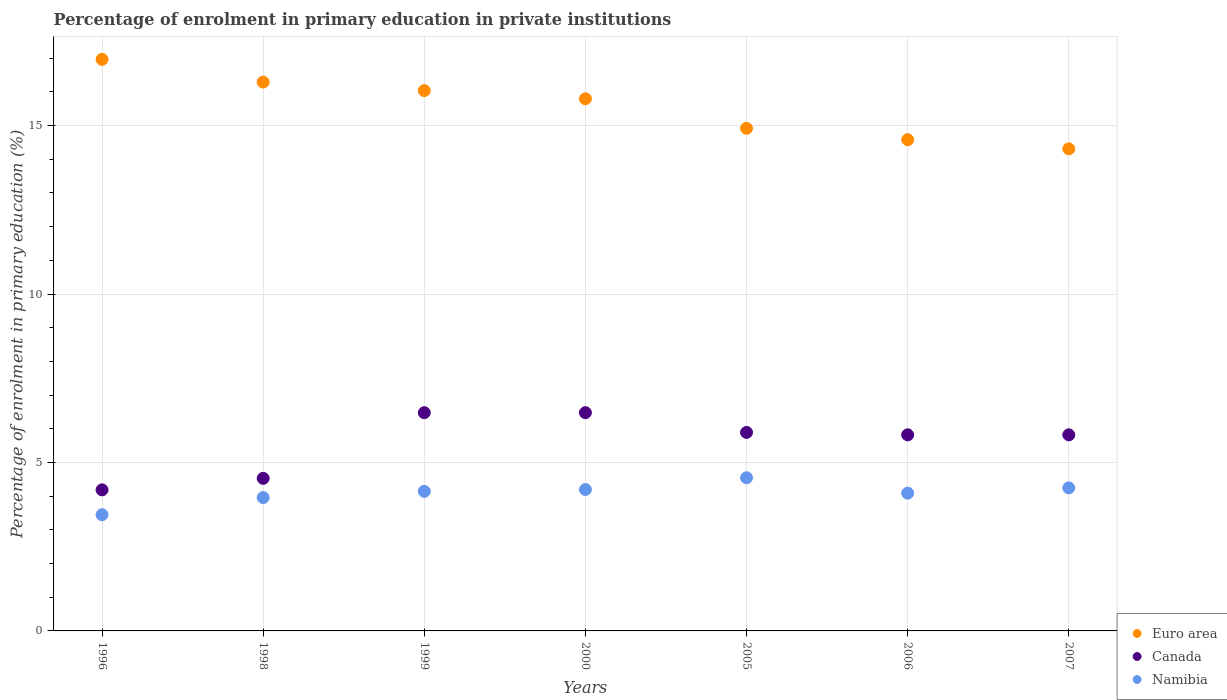What is the percentage of enrolment in primary education in Namibia in 2006?
Ensure brevity in your answer.  4.09. Across all years, what is the maximum percentage of enrolment in primary education in Euro area?
Offer a very short reply. 16.97. Across all years, what is the minimum percentage of enrolment in primary education in Namibia?
Provide a succinct answer. 3.45. In which year was the percentage of enrolment in primary education in Canada maximum?
Provide a succinct answer. 2000. What is the total percentage of enrolment in primary education in Canada in the graph?
Your answer should be very brief. 39.2. What is the difference between the percentage of enrolment in primary education in Namibia in 1996 and that in 1998?
Your response must be concise. -0.51. What is the difference between the percentage of enrolment in primary education in Canada in 1998 and the percentage of enrolment in primary education in Namibia in 1996?
Provide a succinct answer. 1.08. What is the average percentage of enrolment in primary education in Namibia per year?
Offer a terse response. 4.09. In the year 1996, what is the difference between the percentage of enrolment in primary education in Namibia and percentage of enrolment in primary education in Euro area?
Keep it short and to the point. -13.52. What is the ratio of the percentage of enrolment in primary education in Namibia in 2000 to that in 2006?
Offer a very short reply. 1.03. Is the percentage of enrolment in primary education in Canada in 1996 less than that in 2007?
Offer a terse response. Yes. Is the difference between the percentage of enrolment in primary education in Namibia in 1999 and 2000 greater than the difference between the percentage of enrolment in primary education in Euro area in 1999 and 2000?
Make the answer very short. No. What is the difference between the highest and the second highest percentage of enrolment in primary education in Namibia?
Provide a short and direct response. 0.3. What is the difference between the highest and the lowest percentage of enrolment in primary education in Namibia?
Offer a terse response. 1.1. Is it the case that in every year, the sum of the percentage of enrolment in primary education in Euro area and percentage of enrolment in primary education in Canada  is greater than the percentage of enrolment in primary education in Namibia?
Provide a short and direct response. Yes. Does the percentage of enrolment in primary education in Euro area monotonically increase over the years?
Your answer should be very brief. No. How many years are there in the graph?
Offer a terse response. 7. What is the difference between two consecutive major ticks on the Y-axis?
Give a very brief answer. 5. Are the values on the major ticks of Y-axis written in scientific E-notation?
Your answer should be very brief. No. Does the graph contain grids?
Provide a succinct answer. Yes. Where does the legend appear in the graph?
Keep it short and to the point. Bottom right. How many legend labels are there?
Keep it short and to the point. 3. What is the title of the graph?
Give a very brief answer. Percentage of enrolment in primary education in private institutions. What is the label or title of the X-axis?
Offer a terse response. Years. What is the label or title of the Y-axis?
Ensure brevity in your answer.  Percentage of enrolment in primary education (%). What is the Percentage of enrolment in primary education (%) of Euro area in 1996?
Give a very brief answer. 16.97. What is the Percentage of enrolment in primary education (%) in Canada in 1996?
Offer a very short reply. 4.19. What is the Percentage of enrolment in primary education (%) in Namibia in 1996?
Keep it short and to the point. 3.45. What is the Percentage of enrolment in primary education (%) in Euro area in 1998?
Provide a short and direct response. 16.29. What is the Percentage of enrolment in primary education (%) of Canada in 1998?
Give a very brief answer. 4.53. What is the Percentage of enrolment in primary education (%) in Namibia in 1998?
Provide a succinct answer. 3.96. What is the Percentage of enrolment in primary education (%) of Euro area in 1999?
Provide a short and direct response. 16.04. What is the Percentage of enrolment in primary education (%) of Canada in 1999?
Offer a very short reply. 6.48. What is the Percentage of enrolment in primary education (%) of Namibia in 1999?
Provide a succinct answer. 4.14. What is the Percentage of enrolment in primary education (%) of Euro area in 2000?
Ensure brevity in your answer.  15.8. What is the Percentage of enrolment in primary education (%) in Canada in 2000?
Ensure brevity in your answer.  6.48. What is the Percentage of enrolment in primary education (%) in Namibia in 2000?
Your response must be concise. 4.2. What is the Percentage of enrolment in primary education (%) in Euro area in 2005?
Your answer should be compact. 14.92. What is the Percentage of enrolment in primary education (%) of Canada in 2005?
Ensure brevity in your answer.  5.89. What is the Percentage of enrolment in primary education (%) in Namibia in 2005?
Your answer should be very brief. 4.55. What is the Percentage of enrolment in primary education (%) of Euro area in 2006?
Ensure brevity in your answer.  14.58. What is the Percentage of enrolment in primary education (%) in Canada in 2006?
Your answer should be very brief. 5.82. What is the Percentage of enrolment in primary education (%) of Namibia in 2006?
Provide a short and direct response. 4.09. What is the Percentage of enrolment in primary education (%) of Euro area in 2007?
Your response must be concise. 14.31. What is the Percentage of enrolment in primary education (%) of Canada in 2007?
Keep it short and to the point. 5.82. What is the Percentage of enrolment in primary education (%) of Namibia in 2007?
Offer a very short reply. 4.25. Across all years, what is the maximum Percentage of enrolment in primary education (%) in Euro area?
Your response must be concise. 16.97. Across all years, what is the maximum Percentage of enrolment in primary education (%) in Canada?
Your answer should be compact. 6.48. Across all years, what is the maximum Percentage of enrolment in primary education (%) in Namibia?
Your answer should be very brief. 4.55. Across all years, what is the minimum Percentage of enrolment in primary education (%) in Euro area?
Provide a short and direct response. 14.31. Across all years, what is the minimum Percentage of enrolment in primary education (%) in Canada?
Offer a terse response. 4.19. Across all years, what is the minimum Percentage of enrolment in primary education (%) of Namibia?
Give a very brief answer. 3.45. What is the total Percentage of enrolment in primary education (%) of Euro area in the graph?
Ensure brevity in your answer.  108.9. What is the total Percentage of enrolment in primary education (%) in Canada in the graph?
Give a very brief answer. 39.2. What is the total Percentage of enrolment in primary education (%) of Namibia in the graph?
Keep it short and to the point. 28.63. What is the difference between the Percentage of enrolment in primary education (%) of Euro area in 1996 and that in 1998?
Your response must be concise. 0.67. What is the difference between the Percentage of enrolment in primary education (%) in Canada in 1996 and that in 1998?
Offer a terse response. -0.34. What is the difference between the Percentage of enrolment in primary education (%) of Namibia in 1996 and that in 1998?
Your response must be concise. -0.51. What is the difference between the Percentage of enrolment in primary education (%) of Euro area in 1996 and that in 1999?
Provide a succinct answer. 0.93. What is the difference between the Percentage of enrolment in primary education (%) of Canada in 1996 and that in 1999?
Your answer should be very brief. -2.29. What is the difference between the Percentage of enrolment in primary education (%) of Namibia in 1996 and that in 1999?
Your response must be concise. -0.69. What is the difference between the Percentage of enrolment in primary education (%) of Euro area in 1996 and that in 2000?
Keep it short and to the point. 1.17. What is the difference between the Percentage of enrolment in primary education (%) in Canada in 1996 and that in 2000?
Ensure brevity in your answer.  -2.29. What is the difference between the Percentage of enrolment in primary education (%) of Namibia in 1996 and that in 2000?
Give a very brief answer. -0.75. What is the difference between the Percentage of enrolment in primary education (%) of Euro area in 1996 and that in 2005?
Your response must be concise. 2.05. What is the difference between the Percentage of enrolment in primary education (%) of Canada in 1996 and that in 2005?
Your response must be concise. -1.7. What is the difference between the Percentage of enrolment in primary education (%) of Namibia in 1996 and that in 2005?
Your answer should be compact. -1.1. What is the difference between the Percentage of enrolment in primary education (%) of Euro area in 1996 and that in 2006?
Offer a very short reply. 2.39. What is the difference between the Percentage of enrolment in primary education (%) in Canada in 1996 and that in 2006?
Keep it short and to the point. -1.63. What is the difference between the Percentage of enrolment in primary education (%) of Namibia in 1996 and that in 2006?
Give a very brief answer. -0.64. What is the difference between the Percentage of enrolment in primary education (%) of Euro area in 1996 and that in 2007?
Give a very brief answer. 2.66. What is the difference between the Percentage of enrolment in primary education (%) of Canada in 1996 and that in 2007?
Make the answer very short. -1.63. What is the difference between the Percentage of enrolment in primary education (%) of Namibia in 1996 and that in 2007?
Ensure brevity in your answer.  -0.8. What is the difference between the Percentage of enrolment in primary education (%) in Euro area in 1998 and that in 1999?
Give a very brief answer. 0.25. What is the difference between the Percentage of enrolment in primary education (%) in Canada in 1998 and that in 1999?
Offer a very short reply. -1.95. What is the difference between the Percentage of enrolment in primary education (%) in Namibia in 1998 and that in 1999?
Provide a short and direct response. -0.19. What is the difference between the Percentage of enrolment in primary education (%) of Euro area in 1998 and that in 2000?
Keep it short and to the point. 0.5. What is the difference between the Percentage of enrolment in primary education (%) of Canada in 1998 and that in 2000?
Make the answer very short. -1.95. What is the difference between the Percentage of enrolment in primary education (%) of Namibia in 1998 and that in 2000?
Your answer should be very brief. -0.24. What is the difference between the Percentage of enrolment in primary education (%) in Euro area in 1998 and that in 2005?
Keep it short and to the point. 1.37. What is the difference between the Percentage of enrolment in primary education (%) of Canada in 1998 and that in 2005?
Give a very brief answer. -1.36. What is the difference between the Percentage of enrolment in primary education (%) of Namibia in 1998 and that in 2005?
Your response must be concise. -0.59. What is the difference between the Percentage of enrolment in primary education (%) of Euro area in 1998 and that in 2006?
Offer a terse response. 1.71. What is the difference between the Percentage of enrolment in primary education (%) in Canada in 1998 and that in 2006?
Provide a succinct answer. -1.29. What is the difference between the Percentage of enrolment in primary education (%) of Namibia in 1998 and that in 2006?
Provide a succinct answer. -0.13. What is the difference between the Percentage of enrolment in primary education (%) of Euro area in 1998 and that in 2007?
Offer a very short reply. 1.98. What is the difference between the Percentage of enrolment in primary education (%) of Canada in 1998 and that in 2007?
Make the answer very short. -1.29. What is the difference between the Percentage of enrolment in primary education (%) of Namibia in 1998 and that in 2007?
Your response must be concise. -0.29. What is the difference between the Percentage of enrolment in primary education (%) of Euro area in 1999 and that in 2000?
Make the answer very short. 0.24. What is the difference between the Percentage of enrolment in primary education (%) in Canada in 1999 and that in 2000?
Provide a succinct answer. -0. What is the difference between the Percentage of enrolment in primary education (%) of Namibia in 1999 and that in 2000?
Your answer should be very brief. -0.05. What is the difference between the Percentage of enrolment in primary education (%) in Euro area in 1999 and that in 2005?
Your answer should be very brief. 1.12. What is the difference between the Percentage of enrolment in primary education (%) in Canada in 1999 and that in 2005?
Offer a very short reply. 0.59. What is the difference between the Percentage of enrolment in primary education (%) of Namibia in 1999 and that in 2005?
Provide a short and direct response. -0.4. What is the difference between the Percentage of enrolment in primary education (%) in Euro area in 1999 and that in 2006?
Offer a terse response. 1.46. What is the difference between the Percentage of enrolment in primary education (%) in Canada in 1999 and that in 2006?
Provide a short and direct response. 0.66. What is the difference between the Percentage of enrolment in primary education (%) in Namibia in 1999 and that in 2006?
Ensure brevity in your answer.  0.05. What is the difference between the Percentage of enrolment in primary education (%) of Euro area in 1999 and that in 2007?
Make the answer very short. 1.73. What is the difference between the Percentage of enrolment in primary education (%) of Canada in 1999 and that in 2007?
Your response must be concise. 0.66. What is the difference between the Percentage of enrolment in primary education (%) of Namibia in 1999 and that in 2007?
Provide a short and direct response. -0.1. What is the difference between the Percentage of enrolment in primary education (%) of Euro area in 2000 and that in 2005?
Offer a very short reply. 0.88. What is the difference between the Percentage of enrolment in primary education (%) of Canada in 2000 and that in 2005?
Offer a very short reply. 0.59. What is the difference between the Percentage of enrolment in primary education (%) in Namibia in 2000 and that in 2005?
Ensure brevity in your answer.  -0.35. What is the difference between the Percentage of enrolment in primary education (%) in Euro area in 2000 and that in 2006?
Your answer should be very brief. 1.22. What is the difference between the Percentage of enrolment in primary education (%) of Canada in 2000 and that in 2006?
Your answer should be very brief. 0.66. What is the difference between the Percentage of enrolment in primary education (%) of Namibia in 2000 and that in 2006?
Your answer should be very brief. 0.11. What is the difference between the Percentage of enrolment in primary education (%) in Euro area in 2000 and that in 2007?
Provide a short and direct response. 1.49. What is the difference between the Percentage of enrolment in primary education (%) of Canada in 2000 and that in 2007?
Offer a very short reply. 0.66. What is the difference between the Percentage of enrolment in primary education (%) in Namibia in 2000 and that in 2007?
Offer a very short reply. -0.05. What is the difference between the Percentage of enrolment in primary education (%) in Euro area in 2005 and that in 2006?
Offer a terse response. 0.34. What is the difference between the Percentage of enrolment in primary education (%) of Canada in 2005 and that in 2006?
Offer a very short reply. 0.07. What is the difference between the Percentage of enrolment in primary education (%) in Namibia in 2005 and that in 2006?
Make the answer very short. 0.46. What is the difference between the Percentage of enrolment in primary education (%) of Euro area in 2005 and that in 2007?
Provide a succinct answer. 0.61. What is the difference between the Percentage of enrolment in primary education (%) of Canada in 2005 and that in 2007?
Your answer should be very brief. 0.07. What is the difference between the Percentage of enrolment in primary education (%) in Namibia in 2005 and that in 2007?
Offer a very short reply. 0.3. What is the difference between the Percentage of enrolment in primary education (%) of Euro area in 2006 and that in 2007?
Provide a short and direct response. 0.27. What is the difference between the Percentage of enrolment in primary education (%) of Canada in 2006 and that in 2007?
Give a very brief answer. 0. What is the difference between the Percentage of enrolment in primary education (%) of Namibia in 2006 and that in 2007?
Your response must be concise. -0.16. What is the difference between the Percentage of enrolment in primary education (%) of Euro area in 1996 and the Percentage of enrolment in primary education (%) of Canada in 1998?
Offer a terse response. 12.44. What is the difference between the Percentage of enrolment in primary education (%) in Euro area in 1996 and the Percentage of enrolment in primary education (%) in Namibia in 1998?
Make the answer very short. 13.01. What is the difference between the Percentage of enrolment in primary education (%) of Canada in 1996 and the Percentage of enrolment in primary education (%) of Namibia in 1998?
Make the answer very short. 0.23. What is the difference between the Percentage of enrolment in primary education (%) of Euro area in 1996 and the Percentage of enrolment in primary education (%) of Canada in 1999?
Give a very brief answer. 10.49. What is the difference between the Percentage of enrolment in primary education (%) of Euro area in 1996 and the Percentage of enrolment in primary education (%) of Namibia in 1999?
Your answer should be compact. 12.82. What is the difference between the Percentage of enrolment in primary education (%) in Canada in 1996 and the Percentage of enrolment in primary education (%) in Namibia in 1999?
Your response must be concise. 0.04. What is the difference between the Percentage of enrolment in primary education (%) of Euro area in 1996 and the Percentage of enrolment in primary education (%) of Canada in 2000?
Provide a short and direct response. 10.49. What is the difference between the Percentage of enrolment in primary education (%) in Euro area in 1996 and the Percentage of enrolment in primary education (%) in Namibia in 2000?
Ensure brevity in your answer.  12.77. What is the difference between the Percentage of enrolment in primary education (%) of Canada in 1996 and the Percentage of enrolment in primary education (%) of Namibia in 2000?
Your response must be concise. -0.01. What is the difference between the Percentage of enrolment in primary education (%) of Euro area in 1996 and the Percentage of enrolment in primary education (%) of Canada in 2005?
Offer a very short reply. 11.07. What is the difference between the Percentage of enrolment in primary education (%) of Euro area in 1996 and the Percentage of enrolment in primary education (%) of Namibia in 2005?
Offer a terse response. 12.42. What is the difference between the Percentage of enrolment in primary education (%) of Canada in 1996 and the Percentage of enrolment in primary education (%) of Namibia in 2005?
Keep it short and to the point. -0.36. What is the difference between the Percentage of enrolment in primary education (%) in Euro area in 1996 and the Percentage of enrolment in primary education (%) in Canada in 2006?
Keep it short and to the point. 11.15. What is the difference between the Percentage of enrolment in primary education (%) in Euro area in 1996 and the Percentage of enrolment in primary education (%) in Namibia in 2006?
Provide a short and direct response. 12.88. What is the difference between the Percentage of enrolment in primary education (%) of Canada in 1996 and the Percentage of enrolment in primary education (%) of Namibia in 2006?
Make the answer very short. 0.1. What is the difference between the Percentage of enrolment in primary education (%) in Euro area in 1996 and the Percentage of enrolment in primary education (%) in Canada in 2007?
Offer a terse response. 11.15. What is the difference between the Percentage of enrolment in primary education (%) of Euro area in 1996 and the Percentage of enrolment in primary education (%) of Namibia in 2007?
Your response must be concise. 12.72. What is the difference between the Percentage of enrolment in primary education (%) of Canada in 1996 and the Percentage of enrolment in primary education (%) of Namibia in 2007?
Your response must be concise. -0.06. What is the difference between the Percentage of enrolment in primary education (%) in Euro area in 1998 and the Percentage of enrolment in primary education (%) in Canada in 1999?
Your answer should be very brief. 9.81. What is the difference between the Percentage of enrolment in primary education (%) of Euro area in 1998 and the Percentage of enrolment in primary education (%) of Namibia in 1999?
Your response must be concise. 12.15. What is the difference between the Percentage of enrolment in primary education (%) in Canada in 1998 and the Percentage of enrolment in primary education (%) in Namibia in 1999?
Offer a very short reply. 0.39. What is the difference between the Percentage of enrolment in primary education (%) in Euro area in 1998 and the Percentage of enrolment in primary education (%) in Canada in 2000?
Make the answer very short. 9.81. What is the difference between the Percentage of enrolment in primary education (%) in Euro area in 1998 and the Percentage of enrolment in primary education (%) in Namibia in 2000?
Keep it short and to the point. 12.09. What is the difference between the Percentage of enrolment in primary education (%) of Canada in 1998 and the Percentage of enrolment in primary education (%) of Namibia in 2000?
Your response must be concise. 0.33. What is the difference between the Percentage of enrolment in primary education (%) of Euro area in 1998 and the Percentage of enrolment in primary education (%) of Canada in 2005?
Provide a short and direct response. 10.4. What is the difference between the Percentage of enrolment in primary education (%) in Euro area in 1998 and the Percentage of enrolment in primary education (%) in Namibia in 2005?
Keep it short and to the point. 11.74. What is the difference between the Percentage of enrolment in primary education (%) in Canada in 1998 and the Percentage of enrolment in primary education (%) in Namibia in 2005?
Provide a succinct answer. -0.02. What is the difference between the Percentage of enrolment in primary education (%) in Euro area in 1998 and the Percentage of enrolment in primary education (%) in Canada in 2006?
Your response must be concise. 10.47. What is the difference between the Percentage of enrolment in primary education (%) of Euro area in 1998 and the Percentage of enrolment in primary education (%) of Namibia in 2006?
Ensure brevity in your answer.  12.2. What is the difference between the Percentage of enrolment in primary education (%) of Canada in 1998 and the Percentage of enrolment in primary education (%) of Namibia in 2006?
Your answer should be compact. 0.44. What is the difference between the Percentage of enrolment in primary education (%) in Euro area in 1998 and the Percentage of enrolment in primary education (%) in Canada in 2007?
Provide a short and direct response. 10.47. What is the difference between the Percentage of enrolment in primary education (%) of Euro area in 1998 and the Percentage of enrolment in primary education (%) of Namibia in 2007?
Your answer should be compact. 12.04. What is the difference between the Percentage of enrolment in primary education (%) of Canada in 1998 and the Percentage of enrolment in primary education (%) of Namibia in 2007?
Offer a terse response. 0.28. What is the difference between the Percentage of enrolment in primary education (%) of Euro area in 1999 and the Percentage of enrolment in primary education (%) of Canada in 2000?
Ensure brevity in your answer.  9.56. What is the difference between the Percentage of enrolment in primary education (%) of Euro area in 1999 and the Percentage of enrolment in primary education (%) of Namibia in 2000?
Make the answer very short. 11.84. What is the difference between the Percentage of enrolment in primary education (%) of Canada in 1999 and the Percentage of enrolment in primary education (%) of Namibia in 2000?
Provide a succinct answer. 2.28. What is the difference between the Percentage of enrolment in primary education (%) in Euro area in 1999 and the Percentage of enrolment in primary education (%) in Canada in 2005?
Your answer should be compact. 10.15. What is the difference between the Percentage of enrolment in primary education (%) of Euro area in 1999 and the Percentage of enrolment in primary education (%) of Namibia in 2005?
Offer a terse response. 11.49. What is the difference between the Percentage of enrolment in primary education (%) in Canada in 1999 and the Percentage of enrolment in primary education (%) in Namibia in 2005?
Provide a succinct answer. 1.93. What is the difference between the Percentage of enrolment in primary education (%) in Euro area in 1999 and the Percentage of enrolment in primary education (%) in Canada in 2006?
Your response must be concise. 10.22. What is the difference between the Percentage of enrolment in primary education (%) in Euro area in 1999 and the Percentage of enrolment in primary education (%) in Namibia in 2006?
Keep it short and to the point. 11.95. What is the difference between the Percentage of enrolment in primary education (%) of Canada in 1999 and the Percentage of enrolment in primary education (%) of Namibia in 2006?
Make the answer very short. 2.39. What is the difference between the Percentage of enrolment in primary education (%) in Euro area in 1999 and the Percentage of enrolment in primary education (%) in Canada in 2007?
Offer a very short reply. 10.22. What is the difference between the Percentage of enrolment in primary education (%) of Euro area in 1999 and the Percentage of enrolment in primary education (%) of Namibia in 2007?
Your answer should be compact. 11.79. What is the difference between the Percentage of enrolment in primary education (%) of Canada in 1999 and the Percentage of enrolment in primary education (%) of Namibia in 2007?
Make the answer very short. 2.23. What is the difference between the Percentage of enrolment in primary education (%) of Euro area in 2000 and the Percentage of enrolment in primary education (%) of Canada in 2005?
Offer a terse response. 9.9. What is the difference between the Percentage of enrolment in primary education (%) in Euro area in 2000 and the Percentage of enrolment in primary education (%) in Namibia in 2005?
Your answer should be very brief. 11.25. What is the difference between the Percentage of enrolment in primary education (%) in Canada in 2000 and the Percentage of enrolment in primary education (%) in Namibia in 2005?
Give a very brief answer. 1.93. What is the difference between the Percentage of enrolment in primary education (%) in Euro area in 2000 and the Percentage of enrolment in primary education (%) in Canada in 2006?
Provide a short and direct response. 9.98. What is the difference between the Percentage of enrolment in primary education (%) in Euro area in 2000 and the Percentage of enrolment in primary education (%) in Namibia in 2006?
Offer a very short reply. 11.71. What is the difference between the Percentage of enrolment in primary education (%) of Canada in 2000 and the Percentage of enrolment in primary education (%) of Namibia in 2006?
Offer a very short reply. 2.39. What is the difference between the Percentage of enrolment in primary education (%) in Euro area in 2000 and the Percentage of enrolment in primary education (%) in Canada in 2007?
Offer a very short reply. 9.98. What is the difference between the Percentage of enrolment in primary education (%) of Euro area in 2000 and the Percentage of enrolment in primary education (%) of Namibia in 2007?
Your answer should be very brief. 11.55. What is the difference between the Percentage of enrolment in primary education (%) in Canada in 2000 and the Percentage of enrolment in primary education (%) in Namibia in 2007?
Provide a short and direct response. 2.23. What is the difference between the Percentage of enrolment in primary education (%) in Euro area in 2005 and the Percentage of enrolment in primary education (%) in Canada in 2006?
Provide a short and direct response. 9.1. What is the difference between the Percentage of enrolment in primary education (%) of Euro area in 2005 and the Percentage of enrolment in primary education (%) of Namibia in 2006?
Provide a short and direct response. 10.83. What is the difference between the Percentage of enrolment in primary education (%) of Canada in 2005 and the Percentage of enrolment in primary education (%) of Namibia in 2006?
Offer a very short reply. 1.8. What is the difference between the Percentage of enrolment in primary education (%) of Euro area in 2005 and the Percentage of enrolment in primary education (%) of Canada in 2007?
Give a very brief answer. 9.1. What is the difference between the Percentage of enrolment in primary education (%) in Euro area in 2005 and the Percentage of enrolment in primary education (%) in Namibia in 2007?
Keep it short and to the point. 10.67. What is the difference between the Percentage of enrolment in primary education (%) in Canada in 2005 and the Percentage of enrolment in primary education (%) in Namibia in 2007?
Your answer should be very brief. 1.65. What is the difference between the Percentage of enrolment in primary education (%) in Euro area in 2006 and the Percentage of enrolment in primary education (%) in Canada in 2007?
Provide a short and direct response. 8.76. What is the difference between the Percentage of enrolment in primary education (%) of Euro area in 2006 and the Percentage of enrolment in primary education (%) of Namibia in 2007?
Your response must be concise. 10.33. What is the difference between the Percentage of enrolment in primary education (%) in Canada in 2006 and the Percentage of enrolment in primary education (%) in Namibia in 2007?
Offer a terse response. 1.57. What is the average Percentage of enrolment in primary education (%) of Euro area per year?
Ensure brevity in your answer.  15.56. What is the average Percentage of enrolment in primary education (%) in Canada per year?
Provide a succinct answer. 5.6. What is the average Percentage of enrolment in primary education (%) in Namibia per year?
Your answer should be compact. 4.09. In the year 1996, what is the difference between the Percentage of enrolment in primary education (%) in Euro area and Percentage of enrolment in primary education (%) in Canada?
Ensure brevity in your answer.  12.78. In the year 1996, what is the difference between the Percentage of enrolment in primary education (%) of Euro area and Percentage of enrolment in primary education (%) of Namibia?
Your answer should be compact. 13.52. In the year 1996, what is the difference between the Percentage of enrolment in primary education (%) of Canada and Percentage of enrolment in primary education (%) of Namibia?
Offer a very short reply. 0.74. In the year 1998, what is the difference between the Percentage of enrolment in primary education (%) in Euro area and Percentage of enrolment in primary education (%) in Canada?
Provide a succinct answer. 11.76. In the year 1998, what is the difference between the Percentage of enrolment in primary education (%) in Euro area and Percentage of enrolment in primary education (%) in Namibia?
Your answer should be compact. 12.33. In the year 1998, what is the difference between the Percentage of enrolment in primary education (%) in Canada and Percentage of enrolment in primary education (%) in Namibia?
Give a very brief answer. 0.57. In the year 1999, what is the difference between the Percentage of enrolment in primary education (%) of Euro area and Percentage of enrolment in primary education (%) of Canada?
Provide a succinct answer. 9.56. In the year 1999, what is the difference between the Percentage of enrolment in primary education (%) of Euro area and Percentage of enrolment in primary education (%) of Namibia?
Your response must be concise. 11.89. In the year 1999, what is the difference between the Percentage of enrolment in primary education (%) in Canada and Percentage of enrolment in primary education (%) in Namibia?
Ensure brevity in your answer.  2.33. In the year 2000, what is the difference between the Percentage of enrolment in primary education (%) of Euro area and Percentage of enrolment in primary education (%) of Canada?
Make the answer very short. 9.32. In the year 2000, what is the difference between the Percentage of enrolment in primary education (%) in Euro area and Percentage of enrolment in primary education (%) in Namibia?
Give a very brief answer. 11.6. In the year 2000, what is the difference between the Percentage of enrolment in primary education (%) of Canada and Percentage of enrolment in primary education (%) of Namibia?
Your response must be concise. 2.28. In the year 2005, what is the difference between the Percentage of enrolment in primary education (%) of Euro area and Percentage of enrolment in primary education (%) of Canada?
Ensure brevity in your answer.  9.03. In the year 2005, what is the difference between the Percentage of enrolment in primary education (%) of Euro area and Percentage of enrolment in primary education (%) of Namibia?
Your answer should be compact. 10.37. In the year 2005, what is the difference between the Percentage of enrolment in primary education (%) of Canada and Percentage of enrolment in primary education (%) of Namibia?
Offer a very short reply. 1.35. In the year 2006, what is the difference between the Percentage of enrolment in primary education (%) in Euro area and Percentage of enrolment in primary education (%) in Canada?
Provide a short and direct response. 8.76. In the year 2006, what is the difference between the Percentage of enrolment in primary education (%) in Euro area and Percentage of enrolment in primary education (%) in Namibia?
Your answer should be compact. 10.49. In the year 2006, what is the difference between the Percentage of enrolment in primary education (%) in Canada and Percentage of enrolment in primary education (%) in Namibia?
Offer a very short reply. 1.73. In the year 2007, what is the difference between the Percentage of enrolment in primary education (%) in Euro area and Percentage of enrolment in primary education (%) in Canada?
Your answer should be compact. 8.49. In the year 2007, what is the difference between the Percentage of enrolment in primary education (%) of Euro area and Percentage of enrolment in primary education (%) of Namibia?
Offer a terse response. 10.06. In the year 2007, what is the difference between the Percentage of enrolment in primary education (%) of Canada and Percentage of enrolment in primary education (%) of Namibia?
Your answer should be compact. 1.57. What is the ratio of the Percentage of enrolment in primary education (%) of Euro area in 1996 to that in 1998?
Give a very brief answer. 1.04. What is the ratio of the Percentage of enrolment in primary education (%) of Canada in 1996 to that in 1998?
Keep it short and to the point. 0.92. What is the ratio of the Percentage of enrolment in primary education (%) of Namibia in 1996 to that in 1998?
Offer a terse response. 0.87. What is the ratio of the Percentage of enrolment in primary education (%) of Euro area in 1996 to that in 1999?
Provide a succinct answer. 1.06. What is the ratio of the Percentage of enrolment in primary education (%) of Canada in 1996 to that in 1999?
Give a very brief answer. 0.65. What is the ratio of the Percentage of enrolment in primary education (%) of Namibia in 1996 to that in 1999?
Your response must be concise. 0.83. What is the ratio of the Percentage of enrolment in primary education (%) of Euro area in 1996 to that in 2000?
Keep it short and to the point. 1.07. What is the ratio of the Percentage of enrolment in primary education (%) of Canada in 1996 to that in 2000?
Keep it short and to the point. 0.65. What is the ratio of the Percentage of enrolment in primary education (%) in Namibia in 1996 to that in 2000?
Make the answer very short. 0.82. What is the ratio of the Percentage of enrolment in primary education (%) in Euro area in 1996 to that in 2005?
Your answer should be very brief. 1.14. What is the ratio of the Percentage of enrolment in primary education (%) of Canada in 1996 to that in 2005?
Your answer should be compact. 0.71. What is the ratio of the Percentage of enrolment in primary education (%) of Namibia in 1996 to that in 2005?
Keep it short and to the point. 0.76. What is the ratio of the Percentage of enrolment in primary education (%) in Euro area in 1996 to that in 2006?
Give a very brief answer. 1.16. What is the ratio of the Percentage of enrolment in primary education (%) in Canada in 1996 to that in 2006?
Your response must be concise. 0.72. What is the ratio of the Percentage of enrolment in primary education (%) of Namibia in 1996 to that in 2006?
Give a very brief answer. 0.84. What is the ratio of the Percentage of enrolment in primary education (%) in Euro area in 1996 to that in 2007?
Your answer should be very brief. 1.19. What is the ratio of the Percentage of enrolment in primary education (%) of Canada in 1996 to that in 2007?
Provide a succinct answer. 0.72. What is the ratio of the Percentage of enrolment in primary education (%) of Namibia in 1996 to that in 2007?
Keep it short and to the point. 0.81. What is the ratio of the Percentage of enrolment in primary education (%) of Euro area in 1998 to that in 1999?
Provide a short and direct response. 1.02. What is the ratio of the Percentage of enrolment in primary education (%) in Canada in 1998 to that in 1999?
Provide a short and direct response. 0.7. What is the ratio of the Percentage of enrolment in primary education (%) in Namibia in 1998 to that in 1999?
Your answer should be very brief. 0.96. What is the ratio of the Percentage of enrolment in primary education (%) in Euro area in 1998 to that in 2000?
Your answer should be very brief. 1.03. What is the ratio of the Percentage of enrolment in primary education (%) in Canada in 1998 to that in 2000?
Ensure brevity in your answer.  0.7. What is the ratio of the Percentage of enrolment in primary education (%) in Namibia in 1998 to that in 2000?
Keep it short and to the point. 0.94. What is the ratio of the Percentage of enrolment in primary education (%) of Euro area in 1998 to that in 2005?
Give a very brief answer. 1.09. What is the ratio of the Percentage of enrolment in primary education (%) of Canada in 1998 to that in 2005?
Your answer should be compact. 0.77. What is the ratio of the Percentage of enrolment in primary education (%) of Namibia in 1998 to that in 2005?
Your answer should be very brief. 0.87. What is the ratio of the Percentage of enrolment in primary education (%) in Euro area in 1998 to that in 2006?
Your answer should be compact. 1.12. What is the ratio of the Percentage of enrolment in primary education (%) of Canada in 1998 to that in 2006?
Ensure brevity in your answer.  0.78. What is the ratio of the Percentage of enrolment in primary education (%) in Namibia in 1998 to that in 2006?
Keep it short and to the point. 0.97. What is the ratio of the Percentage of enrolment in primary education (%) of Euro area in 1998 to that in 2007?
Make the answer very short. 1.14. What is the ratio of the Percentage of enrolment in primary education (%) of Canada in 1998 to that in 2007?
Make the answer very short. 0.78. What is the ratio of the Percentage of enrolment in primary education (%) of Namibia in 1998 to that in 2007?
Keep it short and to the point. 0.93. What is the ratio of the Percentage of enrolment in primary education (%) of Euro area in 1999 to that in 2000?
Offer a terse response. 1.02. What is the ratio of the Percentage of enrolment in primary education (%) in Namibia in 1999 to that in 2000?
Provide a succinct answer. 0.99. What is the ratio of the Percentage of enrolment in primary education (%) of Euro area in 1999 to that in 2005?
Keep it short and to the point. 1.08. What is the ratio of the Percentage of enrolment in primary education (%) of Canada in 1999 to that in 2005?
Ensure brevity in your answer.  1.1. What is the ratio of the Percentage of enrolment in primary education (%) in Namibia in 1999 to that in 2005?
Provide a succinct answer. 0.91. What is the ratio of the Percentage of enrolment in primary education (%) of Euro area in 1999 to that in 2006?
Provide a short and direct response. 1.1. What is the ratio of the Percentage of enrolment in primary education (%) in Canada in 1999 to that in 2006?
Give a very brief answer. 1.11. What is the ratio of the Percentage of enrolment in primary education (%) in Namibia in 1999 to that in 2006?
Provide a succinct answer. 1.01. What is the ratio of the Percentage of enrolment in primary education (%) in Euro area in 1999 to that in 2007?
Offer a terse response. 1.12. What is the ratio of the Percentage of enrolment in primary education (%) of Canada in 1999 to that in 2007?
Your answer should be very brief. 1.11. What is the ratio of the Percentage of enrolment in primary education (%) in Namibia in 1999 to that in 2007?
Provide a succinct answer. 0.98. What is the ratio of the Percentage of enrolment in primary education (%) in Euro area in 2000 to that in 2005?
Keep it short and to the point. 1.06. What is the ratio of the Percentage of enrolment in primary education (%) in Canada in 2000 to that in 2005?
Provide a succinct answer. 1.1. What is the ratio of the Percentage of enrolment in primary education (%) in Namibia in 2000 to that in 2005?
Make the answer very short. 0.92. What is the ratio of the Percentage of enrolment in primary education (%) in Euro area in 2000 to that in 2006?
Your answer should be compact. 1.08. What is the ratio of the Percentage of enrolment in primary education (%) in Canada in 2000 to that in 2006?
Make the answer very short. 1.11. What is the ratio of the Percentage of enrolment in primary education (%) in Namibia in 2000 to that in 2006?
Your answer should be compact. 1.03. What is the ratio of the Percentage of enrolment in primary education (%) in Euro area in 2000 to that in 2007?
Your answer should be very brief. 1.1. What is the ratio of the Percentage of enrolment in primary education (%) in Canada in 2000 to that in 2007?
Give a very brief answer. 1.11. What is the ratio of the Percentage of enrolment in primary education (%) in Namibia in 2000 to that in 2007?
Your answer should be very brief. 0.99. What is the ratio of the Percentage of enrolment in primary education (%) of Euro area in 2005 to that in 2006?
Your answer should be very brief. 1.02. What is the ratio of the Percentage of enrolment in primary education (%) of Canada in 2005 to that in 2006?
Offer a very short reply. 1.01. What is the ratio of the Percentage of enrolment in primary education (%) of Namibia in 2005 to that in 2006?
Offer a terse response. 1.11. What is the ratio of the Percentage of enrolment in primary education (%) in Euro area in 2005 to that in 2007?
Your answer should be compact. 1.04. What is the ratio of the Percentage of enrolment in primary education (%) in Canada in 2005 to that in 2007?
Your answer should be very brief. 1.01. What is the ratio of the Percentage of enrolment in primary education (%) of Namibia in 2005 to that in 2007?
Your response must be concise. 1.07. What is the ratio of the Percentage of enrolment in primary education (%) of Namibia in 2006 to that in 2007?
Provide a succinct answer. 0.96. What is the difference between the highest and the second highest Percentage of enrolment in primary education (%) in Euro area?
Keep it short and to the point. 0.67. What is the difference between the highest and the second highest Percentage of enrolment in primary education (%) in Namibia?
Ensure brevity in your answer.  0.3. What is the difference between the highest and the lowest Percentage of enrolment in primary education (%) in Euro area?
Provide a short and direct response. 2.66. What is the difference between the highest and the lowest Percentage of enrolment in primary education (%) of Canada?
Your response must be concise. 2.29. What is the difference between the highest and the lowest Percentage of enrolment in primary education (%) in Namibia?
Offer a terse response. 1.1. 